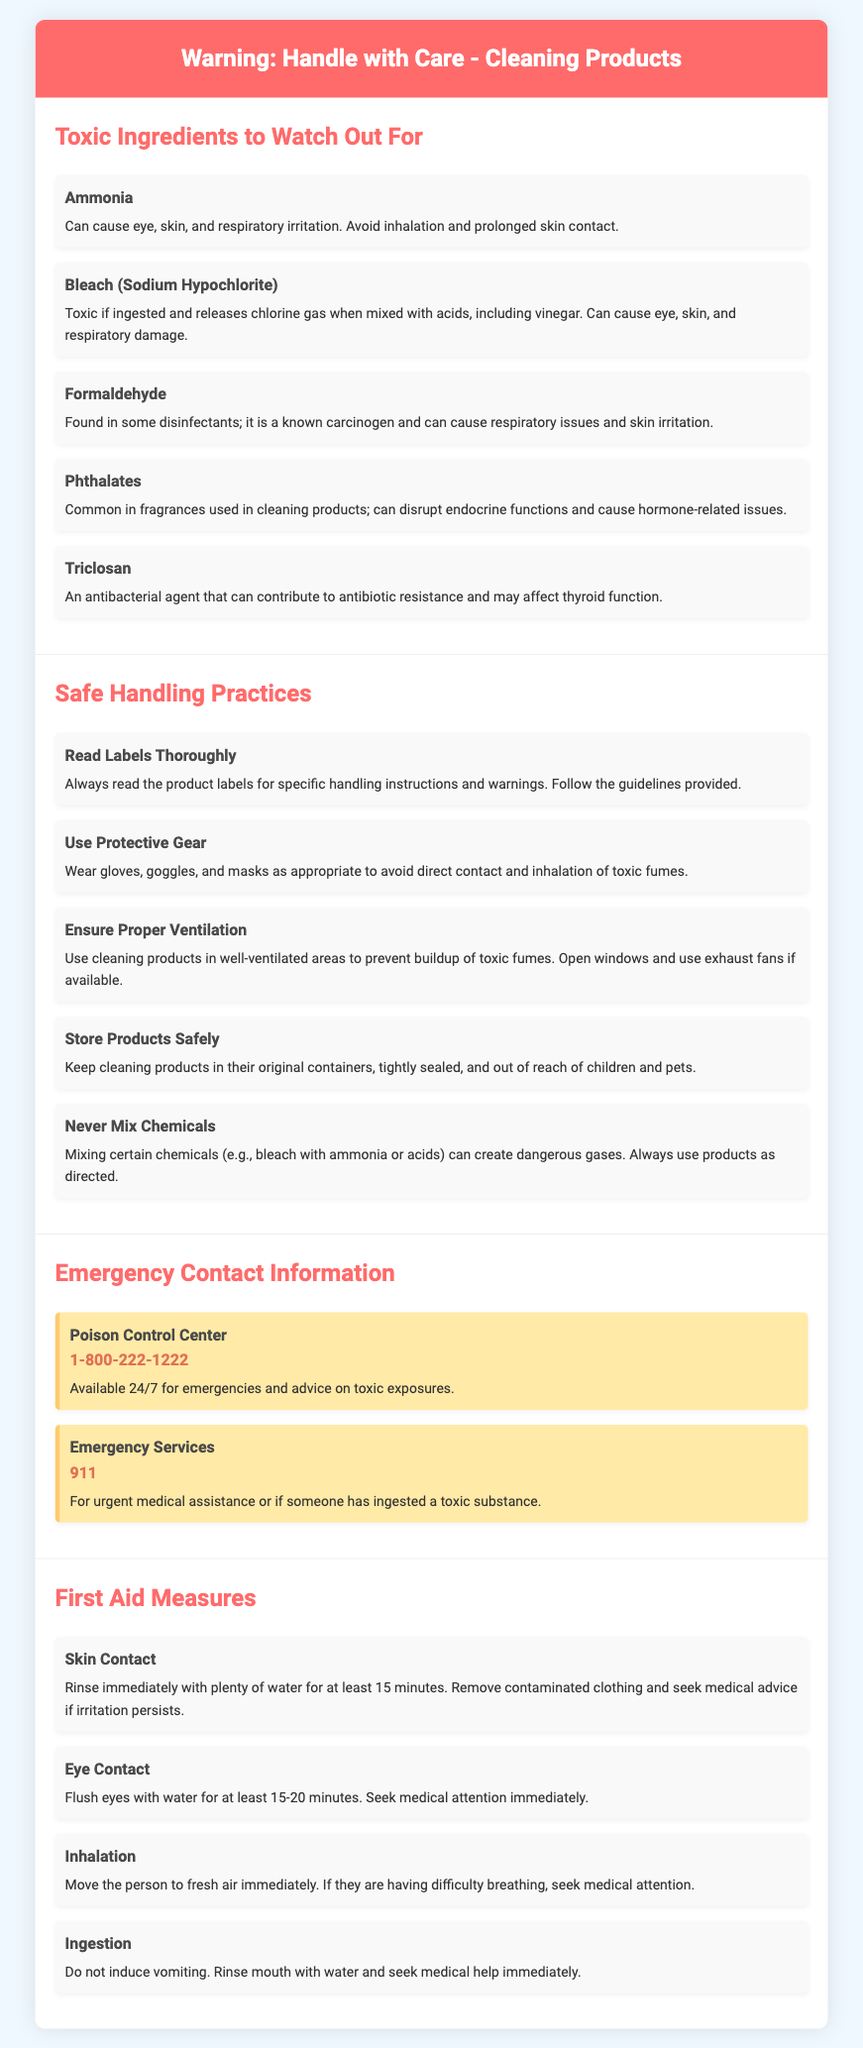What is the first toxic ingredient listed? The document lists ammonia as the first toxic ingredient in the section about toxic ingredients.
Answer: Ammonia What is the emergency contact number for Poison Control Center? The document provides the Poison Control Center's contact number in the emergency contact information section.
Answer: 1-800-222-1222 How many safe handling practices are mentioned? The document enumerates safe handling practices listed under that section.
Answer: Five What ingredient is known as a carcinogen? The document indicates formaldehyde is recognized as a carcinogen.
Answer: Formaldehyde What should you wear as protective gear? The safe handling practices section specifies that gloves, goggles, and masks should be worn.
Answer: Gloves, goggles, and masks Which toxic ingredient can disrupt endocrine functions? Phthalates are mentioned in the document as being able to disrupt endocrine functions.
Answer: Phthalates What is the first aid action for skin contact? The first aid measures section outlines rinsing with water for skin contact.
Answer: Rinse immediately with plenty of water for at least 15 minutes What is the proper action for ingestion? The document states the action to take if someone has ingested a toxic substance.
Answer: Do not induce vomiting What should be done in case of eye contact? The first aid measures section prescribes flushing the eyes with water for eye contact.
Answer: Flush eyes with water for at least 15-20 minutes 